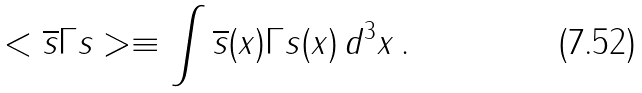<formula> <loc_0><loc_0><loc_500><loc_500>< \overline { s } \Gamma s > \equiv \int \overline { s } ( x ) \Gamma s ( x ) \, d ^ { 3 } x \, .</formula> 